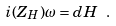Convert formula to latex. <formula><loc_0><loc_0><loc_500><loc_500>i ( Z _ { H } ) \omega = d H \ .</formula> 